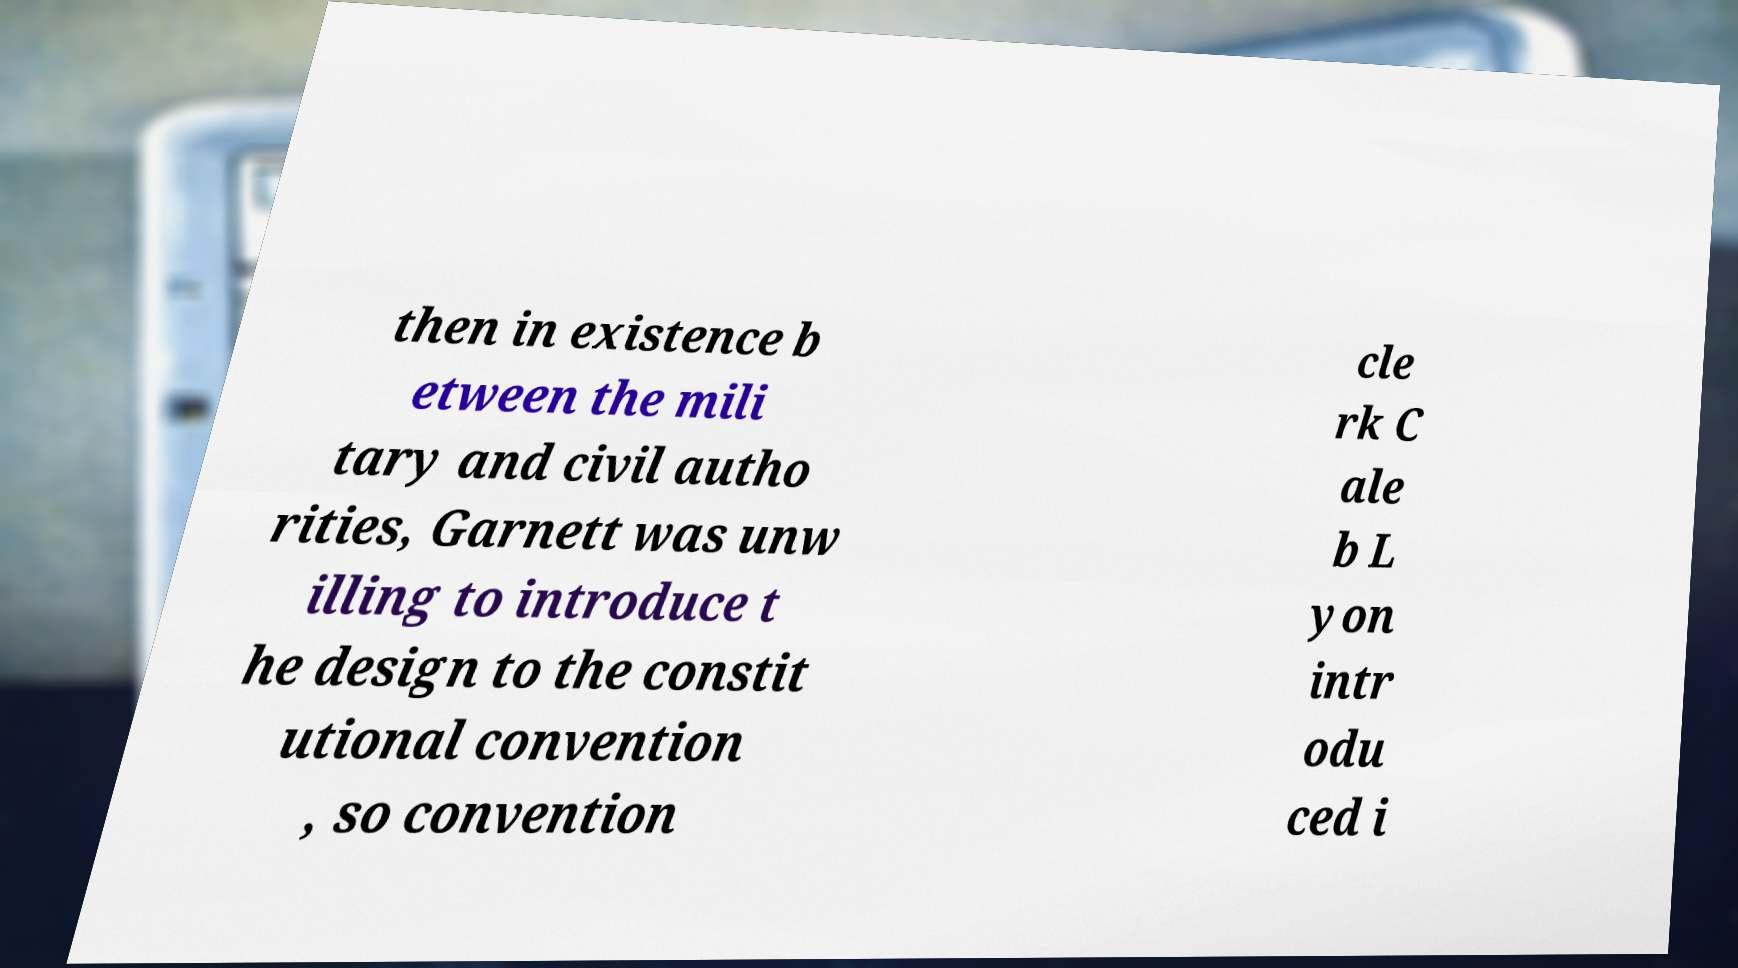I need the written content from this picture converted into text. Can you do that? then in existence b etween the mili tary and civil autho rities, Garnett was unw illing to introduce t he design to the constit utional convention , so convention cle rk C ale b L yon intr odu ced i 